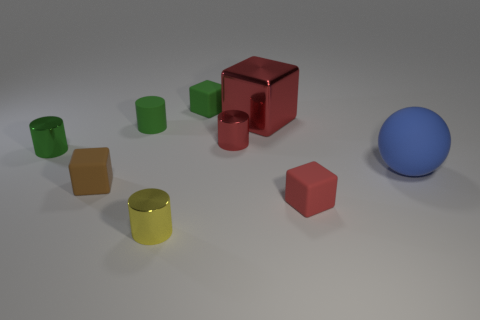Subtract 1 blocks. How many blocks are left? 3 Subtract all gray blocks. Subtract all yellow cylinders. How many blocks are left? 4 Subtract all blocks. How many objects are left? 5 Add 3 green rubber cylinders. How many green rubber cylinders are left? 4 Add 5 blue rubber spheres. How many blue rubber spheres exist? 6 Subtract 1 green cylinders. How many objects are left? 8 Subtract all big blue balls. Subtract all blue rubber balls. How many objects are left? 7 